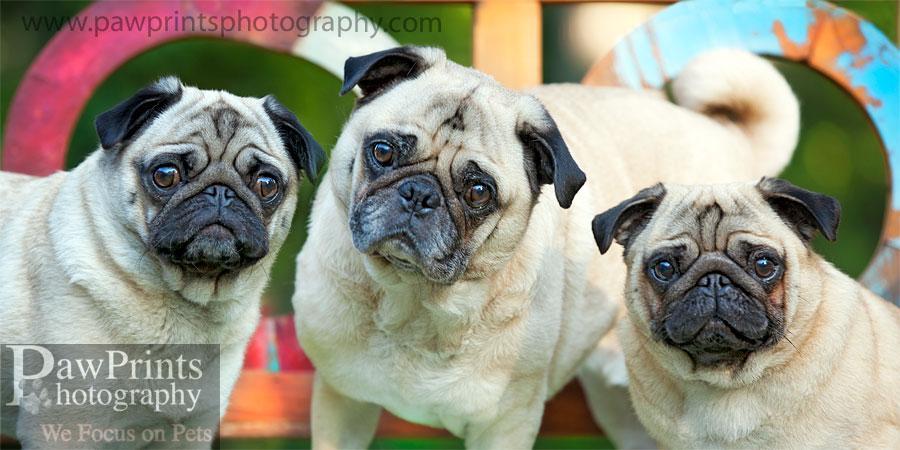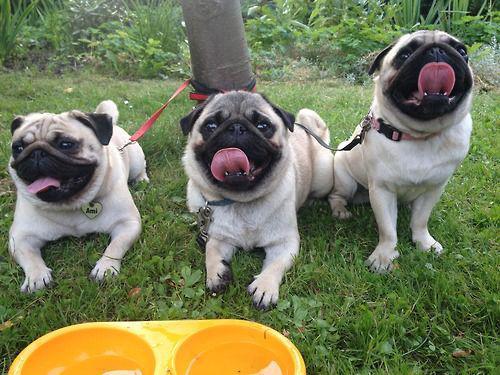The first image is the image on the left, the second image is the image on the right. Analyze the images presented: Is the assertion "A total of five dogs are shown, and all dogs are wearing some type of attire other than an ordinary dog collar." valid? Answer yes or no. No. The first image is the image on the left, the second image is the image on the right. Considering the images on both sides, is "All the dogs in the images are tan pugs." valid? Answer yes or no. Yes. 